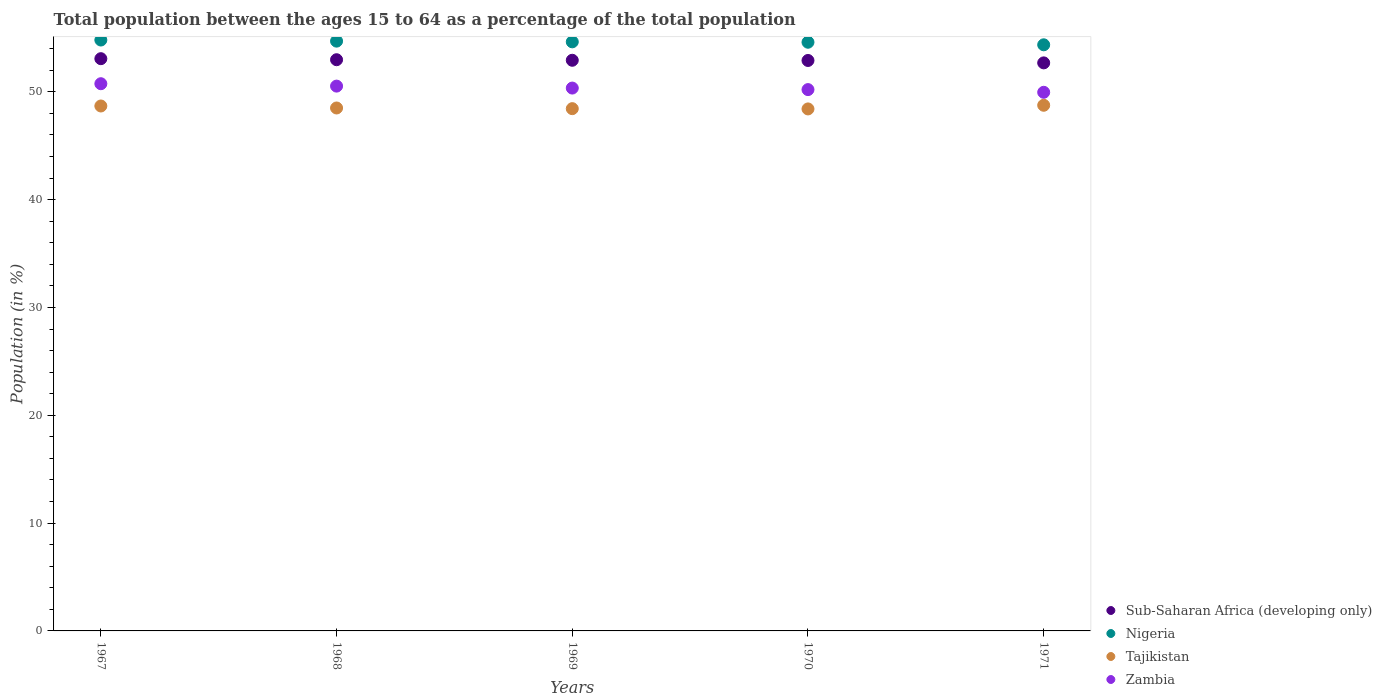How many different coloured dotlines are there?
Your answer should be very brief. 4. Is the number of dotlines equal to the number of legend labels?
Give a very brief answer. Yes. What is the percentage of the population ages 15 to 64 in Nigeria in 1971?
Ensure brevity in your answer.  54.37. Across all years, what is the maximum percentage of the population ages 15 to 64 in Nigeria?
Offer a very short reply. 54.81. Across all years, what is the minimum percentage of the population ages 15 to 64 in Zambia?
Your answer should be very brief. 49.96. In which year was the percentage of the population ages 15 to 64 in Sub-Saharan Africa (developing only) maximum?
Provide a succinct answer. 1967. In which year was the percentage of the population ages 15 to 64 in Nigeria minimum?
Your response must be concise. 1971. What is the total percentage of the population ages 15 to 64 in Zambia in the graph?
Your answer should be very brief. 251.82. What is the difference between the percentage of the population ages 15 to 64 in Zambia in 1968 and that in 1969?
Give a very brief answer. 0.18. What is the difference between the percentage of the population ages 15 to 64 in Tajikistan in 1969 and the percentage of the population ages 15 to 64 in Sub-Saharan Africa (developing only) in 1970?
Keep it short and to the point. -4.47. What is the average percentage of the population ages 15 to 64 in Nigeria per year?
Keep it short and to the point. 54.63. In the year 1968, what is the difference between the percentage of the population ages 15 to 64 in Zambia and percentage of the population ages 15 to 64 in Nigeria?
Your response must be concise. -4.17. What is the ratio of the percentage of the population ages 15 to 64 in Zambia in 1968 to that in 1971?
Provide a short and direct response. 1.01. Is the percentage of the population ages 15 to 64 in Sub-Saharan Africa (developing only) in 1968 less than that in 1971?
Make the answer very short. No. Is the difference between the percentage of the population ages 15 to 64 in Zambia in 1970 and 1971 greater than the difference between the percentage of the population ages 15 to 64 in Nigeria in 1970 and 1971?
Make the answer very short. Yes. What is the difference between the highest and the second highest percentage of the population ages 15 to 64 in Zambia?
Keep it short and to the point. 0.22. What is the difference between the highest and the lowest percentage of the population ages 15 to 64 in Nigeria?
Your answer should be very brief. 0.44. Is the percentage of the population ages 15 to 64 in Sub-Saharan Africa (developing only) strictly less than the percentage of the population ages 15 to 64 in Nigeria over the years?
Provide a succinct answer. Yes. What is the difference between two consecutive major ticks on the Y-axis?
Make the answer very short. 10. Are the values on the major ticks of Y-axis written in scientific E-notation?
Offer a terse response. No. Does the graph contain grids?
Ensure brevity in your answer.  No. Where does the legend appear in the graph?
Your answer should be very brief. Bottom right. How many legend labels are there?
Keep it short and to the point. 4. How are the legend labels stacked?
Your response must be concise. Vertical. What is the title of the graph?
Give a very brief answer. Total population between the ages 15 to 64 as a percentage of the total population. Does "Central Europe" appear as one of the legend labels in the graph?
Your answer should be compact. No. What is the label or title of the X-axis?
Your answer should be compact. Years. What is the Population (in %) in Sub-Saharan Africa (developing only) in 1967?
Provide a short and direct response. 53.08. What is the Population (in %) of Nigeria in 1967?
Your response must be concise. 54.81. What is the Population (in %) in Tajikistan in 1967?
Your response must be concise. 48.69. What is the Population (in %) of Zambia in 1967?
Your answer should be very brief. 50.76. What is the Population (in %) of Sub-Saharan Africa (developing only) in 1968?
Provide a short and direct response. 52.98. What is the Population (in %) in Nigeria in 1968?
Ensure brevity in your answer.  54.71. What is the Population (in %) in Tajikistan in 1968?
Offer a very short reply. 48.51. What is the Population (in %) of Zambia in 1968?
Offer a very short reply. 50.53. What is the Population (in %) in Sub-Saharan Africa (developing only) in 1969?
Keep it short and to the point. 52.93. What is the Population (in %) in Nigeria in 1969?
Your answer should be very brief. 54.64. What is the Population (in %) in Tajikistan in 1969?
Give a very brief answer. 48.44. What is the Population (in %) in Zambia in 1969?
Your response must be concise. 50.35. What is the Population (in %) of Sub-Saharan Africa (developing only) in 1970?
Your response must be concise. 52.91. What is the Population (in %) in Nigeria in 1970?
Provide a succinct answer. 54.6. What is the Population (in %) in Tajikistan in 1970?
Keep it short and to the point. 48.42. What is the Population (in %) in Zambia in 1970?
Give a very brief answer. 50.21. What is the Population (in %) of Sub-Saharan Africa (developing only) in 1971?
Offer a very short reply. 52.69. What is the Population (in %) in Nigeria in 1971?
Your response must be concise. 54.37. What is the Population (in %) of Tajikistan in 1971?
Offer a very short reply. 48.76. What is the Population (in %) of Zambia in 1971?
Your answer should be compact. 49.96. Across all years, what is the maximum Population (in %) in Sub-Saharan Africa (developing only)?
Your answer should be compact. 53.08. Across all years, what is the maximum Population (in %) of Nigeria?
Ensure brevity in your answer.  54.81. Across all years, what is the maximum Population (in %) of Tajikistan?
Your answer should be compact. 48.76. Across all years, what is the maximum Population (in %) of Zambia?
Your response must be concise. 50.76. Across all years, what is the minimum Population (in %) in Sub-Saharan Africa (developing only)?
Provide a short and direct response. 52.69. Across all years, what is the minimum Population (in %) of Nigeria?
Provide a succinct answer. 54.37. Across all years, what is the minimum Population (in %) in Tajikistan?
Give a very brief answer. 48.42. Across all years, what is the minimum Population (in %) of Zambia?
Your answer should be very brief. 49.96. What is the total Population (in %) in Sub-Saharan Africa (developing only) in the graph?
Your answer should be compact. 264.59. What is the total Population (in %) in Nigeria in the graph?
Keep it short and to the point. 273.13. What is the total Population (in %) of Tajikistan in the graph?
Ensure brevity in your answer.  242.81. What is the total Population (in %) in Zambia in the graph?
Offer a very short reply. 251.82. What is the difference between the Population (in %) in Sub-Saharan Africa (developing only) in 1967 and that in 1968?
Your answer should be very brief. 0.1. What is the difference between the Population (in %) of Nigeria in 1967 and that in 1968?
Your response must be concise. 0.1. What is the difference between the Population (in %) in Tajikistan in 1967 and that in 1968?
Your answer should be very brief. 0.19. What is the difference between the Population (in %) in Zambia in 1967 and that in 1968?
Make the answer very short. 0.22. What is the difference between the Population (in %) in Sub-Saharan Africa (developing only) in 1967 and that in 1969?
Make the answer very short. 0.15. What is the difference between the Population (in %) in Nigeria in 1967 and that in 1969?
Make the answer very short. 0.17. What is the difference between the Population (in %) of Tajikistan in 1967 and that in 1969?
Your answer should be compact. 0.25. What is the difference between the Population (in %) of Zambia in 1967 and that in 1969?
Offer a terse response. 0.4. What is the difference between the Population (in %) of Sub-Saharan Africa (developing only) in 1967 and that in 1970?
Provide a succinct answer. 0.17. What is the difference between the Population (in %) of Nigeria in 1967 and that in 1970?
Provide a short and direct response. 0.21. What is the difference between the Population (in %) in Tajikistan in 1967 and that in 1970?
Your answer should be very brief. 0.27. What is the difference between the Population (in %) of Zambia in 1967 and that in 1970?
Make the answer very short. 0.55. What is the difference between the Population (in %) in Sub-Saharan Africa (developing only) in 1967 and that in 1971?
Offer a terse response. 0.39. What is the difference between the Population (in %) of Nigeria in 1967 and that in 1971?
Make the answer very short. 0.44. What is the difference between the Population (in %) of Tajikistan in 1967 and that in 1971?
Give a very brief answer. -0.07. What is the difference between the Population (in %) in Zambia in 1967 and that in 1971?
Offer a terse response. 0.8. What is the difference between the Population (in %) in Sub-Saharan Africa (developing only) in 1968 and that in 1969?
Offer a terse response. 0.05. What is the difference between the Population (in %) in Nigeria in 1968 and that in 1969?
Offer a very short reply. 0.06. What is the difference between the Population (in %) in Tajikistan in 1968 and that in 1969?
Your response must be concise. 0.06. What is the difference between the Population (in %) of Zambia in 1968 and that in 1969?
Provide a succinct answer. 0.18. What is the difference between the Population (in %) in Sub-Saharan Africa (developing only) in 1968 and that in 1970?
Your answer should be compact. 0.07. What is the difference between the Population (in %) in Nigeria in 1968 and that in 1970?
Your response must be concise. 0.1. What is the difference between the Population (in %) in Tajikistan in 1968 and that in 1970?
Your answer should be very brief. 0.09. What is the difference between the Population (in %) of Zambia in 1968 and that in 1970?
Provide a short and direct response. 0.32. What is the difference between the Population (in %) in Sub-Saharan Africa (developing only) in 1968 and that in 1971?
Ensure brevity in your answer.  0.29. What is the difference between the Population (in %) in Nigeria in 1968 and that in 1971?
Offer a terse response. 0.34. What is the difference between the Population (in %) in Tajikistan in 1968 and that in 1971?
Your response must be concise. -0.25. What is the difference between the Population (in %) in Zambia in 1968 and that in 1971?
Provide a succinct answer. 0.57. What is the difference between the Population (in %) of Sub-Saharan Africa (developing only) in 1969 and that in 1970?
Offer a terse response. 0.02. What is the difference between the Population (in %) of Nigeria in 1969 and that in 1970?
Your response must be concise. 0.04. What is the difference between the Population (in %) in Tajikistan in 1969 and that in 1970?
Provide a short and direct response. 0.03. What is the difference between the Population (in %) in Zambia in 1969 and that in 1970?
Your response must be concise. 0.14. What is the difference between the Population (in %) of Sub-Saharan Africa (developing only) in 1969 and that in 1971?
Provide a succinct answer. 0.24. What is the difference between the Population (in %) of Nigeria in 1969 and that in 1971?
Your answer should be very brief. 0.27. What is the difference between the Population (in %) of Tajikistan in 1969 and that in 1971?
Give a very brief answer. -0.31. What is the difference between the Population (in %) in Zambia in 1969 and that in 1971?
Keep it short and to the point. 0.39. What is the difference between the Population (in %) in Sub-Saharan Africa (developing only) in 1970 and that in 1971?
Provide a short and direct response. 0.22. What is the difference between the Population (in %) of Nigeria in 1970 and that in 1971?
Give a very brief answer. 0.24. What is the difference between the Population (in %) of Tajikistan in 1970 and that in 1971?
Your answer should be very brief. -0.34. What is the difference between the Population (in %) of Zambia in 1970 and that in 1971?
Ensure brevity in your answer.  0.25. What is the difference between the Population (in %) in Sub-Saharan Africa (developing only) in 1967 and the Population (in %) in Nigeria in 1968?
Offer a terse response. -1.63. What is the difference between the Population (in %) of Sub-Saharan Africa (developing only) in 1967 and the Population (in %) of Tajikistan in 1968?
Provide a succinct answer. 4.57. What is the difference between the Population (in %) in Sub-Saharan Africa (developing only) in 1967 and the Population (in %) in Zambia in 1968?
Make the answer very short. 2.54. What is the difference between the Population (in %) in Nigeria in 1967 and the Population (in %) in Tajikistan in 1968?
Your answer should be very brief. 6.3. What is the difference between the Population (in %) in Nigeria in 1967 and the Population (in %) in Zambia in 1968?
Provide a succinct answer. 4.27. What is the difference between the Population (in %) of Tajikistan in 1967 and the Population (in %) of Zambia in 1968?
Provide a short and direct response. -1.84. What is the difference between the Population (in %) of Sub-Saharan Africa (developing only) in 1967 and the Population (in %) of Nigeria in 1969?
Provide a succinct answer. -1.56. What is the difference between the Population (in %) in Sub-Saharan Africa (developing only) in 1967 and the Population (in %) in Tajikistan in 1969?
Give a very brief answer. 4.64. What is the difference between the Population (in %) of Sub-Saharan Africa (developing only) in 1967 and the Population (in %) of Zambia in 1969?
Offer a very short reply. 2.73. What is the difference between the Population (in %) in Nigeria in 1967 and the Population (in %) in Tajikistan in 1969?
Your answer should be very brief. 6.37. What is the difference between the Population (in %) in Nigeria in 1967 and the Population (in %) in Zambia in 1969?
Ensure brevity in your answer.  4.46. What is the difference between the Population (in %) in Tajikistan in 1967 and the Population (in %) in Zambia in 1969?
Offer a very short reply. -1.66. What is the difference between the Population (in %) of Sub-Saharan Africa (developing only) in 1967 and the Population (in %) of Nigeria in 1970?
Your answer should be compact. -1.53. What is the difference between the Population (in %) in Sub-Saharan Africa (developing only) in 1967 and the Population (in %) in Tajikistan in 1970?
Your answer should be compact. 4.66. What is the difference between the Population (in %) in Sub-Saharan Africa (developing only) in 1967 and the Population (in %) in Zambia in 1970?
Provide a short and direct response. 2.87. What is the difference between the Population (in %) of Nigeria in 1967 and the Population (in %) of Tajikistan in 1970?
Your answer should be compact. 6.39. What is the difference between the Population (in %) of Nigeria in 1967 and the Population (in %) of Zambia in 1970?
Offer a terse response. 4.6. What is the difference between the Population (in %) of Tajikistan in 1967 and the Population (in %) of Zambia in 1970?
Offer a very short reply. -1.52. What is the difference between the Population (in %) of Sub-Saharan Africa (developing only) in 1967 and the Population (in %) of Nigeria in 1971?
Your answer should be very brief. -1.29. What is the difference between the Population (in %) of Sub-Saharan Africa (developing only) in 1967 and the Population (in %) of Tajikistan in 1971?
Provide a short and direct response. 4.32. What is the difference between the Population (in %) in Sub-Saharan Africa (developing only) in 1967 and the Population (in %) in Zambia in 1971?
Offer a very short reply. 3.12. What is the difference between the Population (in %) of Nigeria in 1967 and the Population (in %) of Tajikistan in 1971?
Provide a short and direct response. 6.05. What is the difference between the Population (in %) in Nigeria in 1967 and the Population (in %) in Zambia in 1971?
Provide a succinct answer. 4.85. What is the difference between the Population (in %) of Tajikistan in 1967 and the Population (in %) of Zambia in 1971?
Your answer should be compact. -1.27. What is the difference between the Population (in %) of Sub-Saharan Africa (developing only) in 1968 and the Population (in %) of Nigeria in 1969?
Keep it short and to the point. -1.66. What is the difference between the Population (in %) in Sub-Saharan Africa (developing only) in 1968 and the Population (in %) in Tajikistan in 1969?
Your answer should be compact. 4.54. What is the difference between the Population (in %) of Sub-Saharan Africa (developing only) in 1968 and the Population (in %) of Zambia in 1969?
Offer a terse response. 2.63. What is the difference between the Population (in %) of Nigeria in 1968 and the Population (in %) of Tajikistan in 1969?
Your response must be concise. 6.26. What is the difference between the Population (in %) of Nigeria in 1968 and the Population (in %) of Zambia in 1969?
Give a very brief answer. 4.35. What is the difference between the Population (in %) in Tajikistan in 1968 and the Population (in %) in Zambia in 1969?
Ensure brevity in your answer.  -1.85. What is the difference between the Population (in %) in Sub-Saharan Africa (developing only) in 1968 and the Population (in %) in Nigeria in 1970?
Your answer should be compact. -1.62. What is the difference between the Population (in %) of Sub-Saharan Africa (developing only) in 1968 and the Population (in %) of Tajikistan in 1970?
Your response must be concise. 4.56. What is the difference between the Population (in %) in Sub-Saharan Africa (developing only) in 1968 and the Population (in %) in Zambia in 1970?
Provide a succinct answer. 2.77. What is the difference between the Population (in %) of Nigeria in 1968 and the Population (in %) of Tajikistan in 1970?
Your answer should be very brief. 6.29. What is the difference between the Population (in %) in Nigeria in 1968 and the Population (in %) in Zambia in 1970?
Your answer should be compact. 4.5. What is the difference between the Population (in %) in Tajikistan in 1968 and the Population (in %) in Zambia in 1970?
Provide a succinct answer. -1.71. What is the difference between the Population (in %) of Sub-Saharan Africa (developing only) in 1968 and the Population (in %) of Nigeria in 1971?
Your answer should be compact. -1.38. What is the difference between the Population (in %) in Sub-Saharan Africa (developing only) in 1968 and the Population (in %) in Tajikistan in 1971?
Provide a succinct answer. 4.22. What is the difference between the Population (in %) in Sub-Saharan Africa (developing only) in 1968 and the Population (in %) in Zambia in 1971?
Offer a terse response. 3.02. What is the difference between the Population (in %) of Nigeria in 1968 and the Population (in %) of Tajikistan in 1971?
Keep it short and to the point. 5.95. What is the difference between the Population (in %) of Nigeria in 1968 and the Population (in %) of Zambia in 1971?
Make the answer very short. 4.75. What is the difference between the Population (in %) in Tajikistan in 1968 and the Population (in %) in Zambia in 1971?
Ensure brevity in your answer.  -1.46. What is the difference between the Population (in %) in Sub-Saharan Africa (developing only) in 1969 and the Population (in %) in Nigeria in 1970?
Offer a very short reply. -1.67. What is the difference between the Population (in %) in Sub-Saharan Africa (developing only) in 1969 and the Population (in %) in Tajikistan in 1970?
Your response must be concise. 4.51. What is the difference between the Population (in %) in Sub-Saharan Africa (developing only) in 1969 and the Population (in %) in Zambia in 1970?
Offer a very short reply. 2.72. What is the difference between the Population (in %) in Nigeria in 1969 and the Population (in %) in Tajikistan in 1970?
Make the answer very short. 6.22. What is the difference between the Population (in %) of Nigeria in 1969 and the Population (in %) of Zambia in 1970?
Give a very brief answer. 4.43. What is the difference between the Population (in %) of Tajikistan in 1969 and the Population (in %) of Zambia in 1970?
Offer a terse response. -1.77. What is the difference between the Population (in %) in Sub-Saharan Africa (developing only) in 1969 and the Population (in %) in Nigeria in 1971?
Offer a very short reply. -1.44. What is the difference between the Population (in %) of Sub-Saharan Africa (developing only) in 1969 and the Population (in %) of Tajikistan in 1971?
Offer a terse response. 4.17. What is the difference between the Population (in %) of Sub-Saharan Africa (developing only) in 1969 and the Population (in %) of Zambia in 1971?
Make the answer very short. 2.97. What is the difference between the Population (in %) in Nigeria in 1969 and the Population (in %) in Tajikistan in 1971?
Provide a short and direct response. 5.88. What is the difference between the Population (in %) in Nigeria in 1969 and the Population (in %) in Zambia in 1971?
Give a very brief answer. 4.68. What is the difference between the Population (in %) in Tajikistan in 1969 and the Population (in %) in Zambia in 1971?
Your answer should be very brief. -1.52. What is the difference between the Population (in %) in Sub-Saharan Africa (developing only) in 1970 and the Population (in %) in Nigeria in 1971?
Make the answer very short. -1.45. What is the difference between the Population (in %) in Sub-Saharan Africa (developing only) in 1970 and the Population (in %) in Tajikistan in 1971?
Your response must be concise. 4.15. What is the difference between the Population (in %) of Sub-Saharan Africa (developing only) in 1970 and the Population (in %) of Zambia in 1971?
Your answer should be compact. 2.95. What is the difference between the Population (in %) in Nigeria in 1970 and the Population (in %) in Tajikistan in 1971?
Your answer should be compact. 5.85. What is the difference between the Population (in %) of Nigeria in 1970 and the Population (in %) of Zambia in 1971?
Make the answer very short. 4.64. What is the difference between the Population (in %) of Tajikistan in 1970 and the Population (in %) of Zambia in 1971?
Offer a terse response. -1.54. What is the average Population (in %) in Sub-Saharan Africa (developing only) per year?
Offer a terse response. 52.92. What is the average Population (in %) of Nigeria per year?
Offer a terse response. 54.63. What is the average Population (in %) in Tajikistan per year?
Make the answer very short. 48.56. What is the average Population (in %) of Zambia per year?
Offer a very short reply. 50.36. In the year 1967, what is the difference between the Population (in %) of Sub-Saharan Africa (developing only) and Population (in %) of Nigeria?
Give a very brief answer. -1.73. In the year 1967, what is the difference between the Population (in %) in Sub-Saharan Africa (developing only) and Population (in %) in Tajikistan?
Your response must be concise. 4.39. In the year 1967, what is the difference between the Population (in %) in Sub-Saharan Africa (developing only) and Population (in %) in Zambia?
Make the answer very short. 2.32. In the year 1967, what is the difference between the Population (in %) of Nigeria and Population (in %) of Tajikistan?
Offer a terse response. 6.12. In the year 1967, what is the difference between the Population (in %) in Nigeria and Population (in %) in Zambia?
Offer a terse response. 4.05. In the year 1967, what is the difference between the Population (in %) of Tajikistan and Population (in %) of Zambia?
Make the answer very short. -2.07. In the year 1968, what is the difference between the Population (in %) of Sub-Saharan Africa (developing only) and Population (in %) of Nigeria?
Ensure brevity in your answer.  -1.72. In the year 1968, what is the difference between the Population (in %) in Sub-Saharan Africa (developing only) and Population (in %) in Tajikistan?
Your response must be concise. 4.48. In the year 1968, what is the difference between the Population (in %) in Sub-Saharan Africa (developing only) and Population (in %) in Zambia?
Give a very brief answer. 2.45. In the year 1968, what is the difference between the Population (in %) of Nigeria and Population (in %) of Tajikistan?
Ensure brevity in your answer.  6.2. In the year 1968, what is the difference between the Population (in %) in Nigeria and Population (in %) in Zambia?
Provide a succinct answer. 4.17. In the year 1968, what is the difference between the Population (in %) in Tajikistan and Population (in %) in Zambia?
Provide a short and direct response. -2.03. In the year 1969, what is the difference between the Population (in %) of Sub-Saharan Africa (developing only) and Population (in %) of Nigeria?
Give a very brief answer. -1.71. In the year 1969, what is the difference between the Population (in %) in Sub-Saharan Africa (developing only) and Population (in %) in Tajikistan?
Provide a succinct answer. 4.49. In the year 1969, what is the difference between the Population (in %) in Sub-Saharan Africa (developing only) and Population (in %) in Zambia?
Offer a very short reply. 2.58. In the year 1969, what is the difference between the Population (in %) in Nigeria and Population (in %) in Tajikistan?
Your response must be concise. 6.2. In the year 1969, what is the difference between the Population (in %) of Nigeria and Population (in %) of Zambia?
Your answer should be very brief. 4.29. In the year 1969, what is the difference between the Population (in %) in Tajikistan and Population (in %) in Zambia?
Offer a terse response. -1.91. In the year 1970, what is the difference between the Population (in %) in Sub-Saharan Africa (developing only) and Population (in %) in Nigeria?
Offer a terse response. -1.69. In the year 1970, what is the difference between the Population (in %) in Sub-Saharan Africa (developing only) and Population (in %) in Tajikistan?
Provide a short and direct response. 4.49. In the year 1970, what is the difference between the Population (in %) in Sub-Saharan Africa (developing only) and Population (in %) in Zambia?
Keep it short and to the point. 2.7. In the year 1970, what is the difference between the Population (in %) of Nigeria and Population (in %) of Tajikistan?
Make the answer very short. 6.19. In the year 1970, what is the difference between the Population (in %) in Nigeria and Population (in %) in Zambia?
Offer a terse response. 4.39. In the year 1970, what is the difference between the Population (in %) in Tajikistan and Population (in %) in Zambia?
Offer a very short reply. -1.79. In the year 1971, what is the difference between the Population (in %) of Sub-Saharan Africa (developing only) and Population (in %) of Nigeria?
Your answer should be very brief. -1.68. In the year 1971, what is the difference between the Population (in %) of Sub-Saharan Africa (developing only) and Population (in %) of Tajikistan?
Ensure brevity in your answer.  3.93. In the year 1971, what is the difference between the Population (in %) of Sub-Saharan Africa (developing only) and Population (in %) of Zambia?
Offer a very short reply. 2.73. In the year 1971, what is the difference between the Population (in %) in Nigeria and Population (in %) in Tajikistan?
Offer a terse response. 5.61. In the year 1971, what is the difference between the Population (in %) in Nigeria and Population (in %) in Zambia?
Keep it short and to the point. 4.41. In the year 1971, what is the difference between the Population (in %) of Tajikistan and Population (in %) of Zambia?
Your answer should be very brief. -1.2. What is the ratio of the Population (in %) of Nigeria in 1967 to that in 1968?
Your answer should be compact. 1. What is the ratio of the Population (in %) of Zambia in 1967 to that in 1968?
Give a very brief answer. 1. What is the ratio of the Population (in %) in Tajikistan in 1967 to that in 1969?
Ensure brevity in your answer.  1.01. What is the ratio of the Population (in %) in Zambia in 1967 to that in 1969?
Offer a terse response. 1.01. What is the ratio of the Population (in %) of Tajikistan in 1967 to that in 1970?
Your answer should be very brief. 1.01. What is the ratio of the Population (in %) in Zambia in 1967 to that in 1970?
Provide a short and direct response. 1.01. What is the ratio of the Population (in %) of Sub-Saharan Africa (developing only) in 1967 to that in 1971?
Your answer should be compact. 1.01. What is the ratio of the Population (in %) of Nigeria in 1967 to that in 1971?
Give a very brief answer. 1.01. What is the ratio of the Population (in %) of Tajikistan in 1967 to that in 1971?
Keep it short and to the point. 1. What is the ratio of the Population (in %) of Zambia in 1967 to that in 1971?
Your answer should be very brief. 1.02. What is the ratio of the Population (in %) in Nigeria in 1968 to that in 1969?
Your answer should be compact. 1. What is the ratio of the Population (in %) in Zambia in 1968 to that in 1969?
Your response must be concise. 1. What is the ratio of the Population (in %) of Sub-Saharan Africa (developing only) in 1968 to that in 1970?
Provide a succinct answer. 1. What is the ratio of the Population (in %) in Nigeria in 1968 to that in 1970?
Offer a very short reply. 1. What is the ratio of the Population (in %) of Tajikistan in 1968 to that in 1970?
Provide a short and direct response. 1. What is the ratio of the Population (in %) of Zambia in 1968 to that in 1970?
Offer a very short reply. 1.01. What is the ratio of the Population (in %) in Sub-Saharan Africa (developing only) in 1968 to that in 1971?
Offer a terse response. 1.01. What is the ratio of the Population (in %) of Nigeria in 1968 to that in 1971?
Your answer should be very brief. 1.01. What is the ratio of the Population (in %) of Tajikistan in 1968 to that in 1971?
Give a very brief answer. 0.99. What is the ratio of the Population (in %) in Zambia in 1968 to that in 1971?
Keep it short and to the point. 1.01. What is the ratio of the Population (in %) in Sub-Saharan Africa (developing only) in 1969 to that in 1970?
Your answer should be very brief. 1. What is the ratio of the Population (in %) in Nigeria in 1969 to that in 1970?
Keep it short and to the point. 1. What is the ratio of the Population (in %) of Zambia in 1969 to that in 1970?
Make the answer very short. 1. What is the ratio of the Population (in %) of Zambia in 1969 to that in 1971?
Offer a terse response. 1.01. What is the difference between the highest and the second highest Population (in %) of Sub-Saharan Africa (developing only)?
Your answer should be very brief. 0.1. What is the difference between the highest and the second highest Population (in %) in Nigeria?
Provide a succinct answer. 0.1. What is the difference between the highest and the second highest Population (in %) of Tajikistan?
Provide a succinct answer. 0.07. What is the difference between the highest and the second highest Population (in %) in Zambia?
Provide a short and direct response. 0.22. What is the difference between the highest and the lowest Population (in %) in Sub-Saharan Africa (developing only)?
Provide a succinct answer. 0.39. What is the difference between the highest and the lowest Population (in %) in Nigeria?
Make the answer very short. 0.44. What is the difference between the highest and the lowest Population (in %) in Tajikistan?
Provide a succinct answer. 0.34. What is the difference between the highest and the lowest Population (in %) in Zambia?
Offer a very short reply. 0.8. 